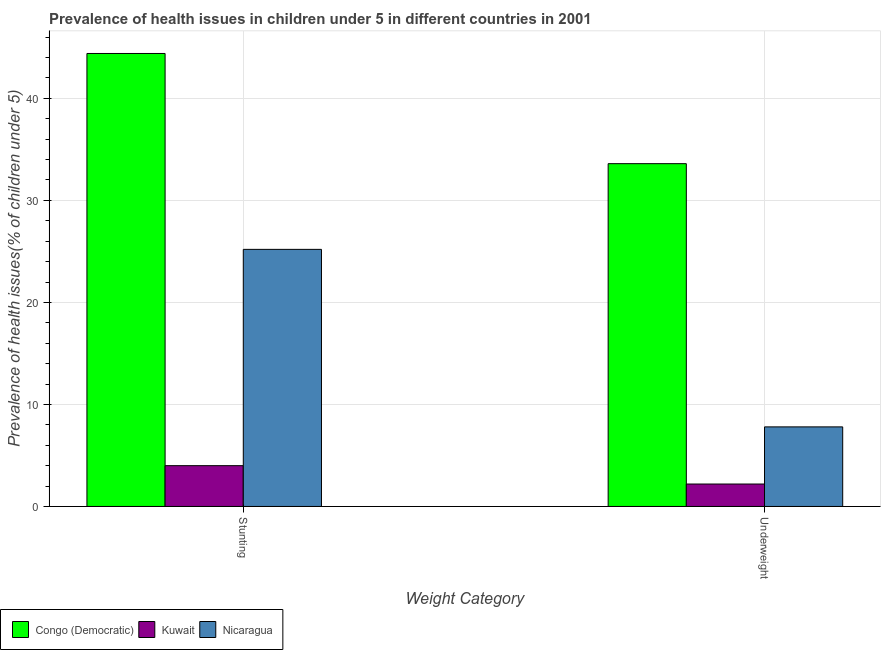Are the number of bars on each tick of the X-axis equal?
Give a very brief answer. Yes. How many bars are there on the 1st tick from the left?
Your answer should be compact. 3. How many bars are there on the 1st tick from the right?
Make the answer very short. 3. What is the label of the 2nd group of bars from the left?
Your answer should be very brief. Underweight. What is the percentage of stunted children in Nicaragua?
Your answer should be compact. 25.2. Across all countries, what is the maximum percentage of stunted children?
Provide a succinct answer. 44.4. Across all countries, what is the minimum percentage of underweight children?
Keep it short and to the point. 2.2. In which country was the percentage of underweight children maximum?
Ensure brevity in your answer.  Congo (Democratic). In which country was the percentage of underweight children minimum?
Ensure brevity in your answer.  Kuwait. What is the total percentage of underweight children in the graph?
Your answer should be very brief. 43.6. What is the difference between the percentage of underweight children in Congo (Democratic) and that in Nicaragua?
Offer a very short reply. 25.8. What is the difference between the percentage of underweight children in Nicaragua and the percentage of stunted children in Kuwait?
Offer a very short reply. 3.8. What is the average percentage of stunted children per country?
Keep it short and to the point. 24.53. What is the difference between the percentage of stunted children and percentage of underweight children in Kuwait?
Provide a succinct answer. 1.8. What is the ratio of the percentage of underweight children in Nicaragua to that in Kuwait?
Keep it short and to the point. 3.55. In how many countries, is the percentage of underweight children greater than the average percentage of underweight children taken over all countries?
Your response must be concise. 1. What does the 2nd bar from the left in Underweight represents?
Keep it short and to the point. Kuwait. What does the 2nd bar from the right in Underweight represents?
Your answer should be compact. Kuwait. Are all the bars in the graph horizontal?
Your response must be concise. No. Are the values on the major ticks of Y-axis written in scientific E-notation?
Offer a terse response. No. Does the graph contain any zero values?
Your response must be concise. No. Does the graph contain grids?
Offer a terse response. Yes. Where does the legend appear in the graph?
Your response must be concise. Bottom left. What is the title of the graph?
Your answer should be very brief. Prevalence of health issues in children under 5 in different countries in 2001. Does "Curacao" appear as one of the legend labels in the graph?
Offer a terse response. No. What is the label or title of the X-axis?
Give a very brief answer. Weight Category. What is the label or title of the Y-axis?
Make the answer very short. Prevalence of health issues(% of children under 5). What is the Prevalence of health issues(% of children under 5) in Congo (Democratic) in Stunting?
Your response must be concise. 44.4. What is the Prevalence of health issues(% of children under 5) of Nicaragua in Stunting?
Your answer should be compact. 25.2. What is the Prevalence of health issues(% of children under 5) in Congo (Democratic) in Underweight?
Your response must be concise. 33.6. What is the Prevalence of health issues(% of children under 5) in Kuwait in Underweight?
Ensure brevity in your answer.  2.2. What is the Prevalence of health issues(% of children under 5) in Nicaragua in Underweight?
Give a very brief answer. 7.8. Across all Weight Category, what is the maximum Prevalence of health issues(% of children under 5) of Congo (Democratic)?
Give a very brief answer. 44.4. Across all Weight Category, what is the maximum Prevalence of health issues(% of children under 5) of Kuwait?
Your answer should be very brief. 4. Across all Weight Category, what is the maximum Prevalence of health issues(% of children under 5) in Nicaragua?
Your answer should be compact. 25.2. Across all Weight Category, what is the minimum Prevalence of health issues(% of children under 5) in Congo (Democratic)?
Offer a very short reply. 33.6. Across all Weight Category, what is the minimum Prevalence of health issues(% of children under 5) of Kuwait?
Your answer should be compact. 2.2. Across all Weight Category, what is the minimum Prevalence of health issues(% of children under 5) in Nicaragua?
Provide a succinct answer. 7.8. What is the total Prevalence of health issues(% of children under 5) of Congo (Democratic) in the graph?
Your answer should be very brief. 78. What is the total Prevalence of health issues(% of children under 5) in Kuwait in the graph?
Keep it short and to the point. 6.2. What is the total Prevalence of health issues(% of children under 5) of Nicaragua in the graph?
Provide a short and direct response. 33. What is the difference between the Prevalence of health issues(% of children under 5) in Kuwait in Stunting and that in Underweight?
Your answer should be compact. 1.8. What is the difference between the Prevalence of health issues(% of children under 5) in Nicaragua in Stunting and that in Underweight?
Make the answer very short. 17.4. What is the difference between the Prevalence of health issues(% of children under 5) in Congo (Democratic) in Stunting and the Prevalence of health issues(% of children under 5) in Kuwait in Underweight?
Offer a terse response. 42.2. What is the difference between the Prevalence of health issues(% of children under 5) of Congo (Democratic) in Stunting and the Prevalence of health issues(% of children under 5) of Nicaragua in Underweight?
Make the answer very short. 36.6. What is the difference between the Prevalence of health issues(% of children under 5) in Kuwait in Stunting and the Prevalence of health issues(% of children under 5) in Nicaragua in Underweight?
Your response must be concise. -3.8. What is the average Prevalence of health issues(% of children under 5) in Congo (Democratic) per Weight Category?
Your answer should be compact. 39. What is the difference between the Prevalence of health issues(% of children under 5) in Congo (Democratic) and Prevalence of health issues(% of children under 5) in Kuwait in Stunting?
Offer a terse response. 40.4. What is the difference between the Prevalence of health issues(% of children under 5) in Congo (Democratic) and Prevalence of health issues(% of children under 5) in Nicaragua in Stunting?
Offer a very short reply. 19.2. What is the difference between the Prevalence of health issues(% of children under 5) in Kuwait and Prevalence of health issues(% of children under 5) in Nicaragua in Stunting?
Give a very brief answer. -21.2. What is the difference between the Prevalence of health issues(% of children under 5) in Congo (Democratic) and Prevalence of health issues(% of children under 5) in Kuwait in Underweight?
Keep it short and to the point. 31.4. What is the difference between the Prevalence of health issues(% of children under 5) in Congo (Democratic) and Prevalence of health issues(% of children under 5) in Nicaragua in Underweight?
Your answer should be very brief. 25.8. What is the difference between the Prevalence of health issues(% of children under 5) of Kuwait and Prevalence of health issues(% of children under 5) of Nicaragua in Underweight?
Offer a very short reply. -5.6. What is the ratio of the Prevalence of health issues(% of children under 5) in Congo (Democratic) in Stunting to that in Underweight?
Make the answer very short. 1.32. What is the ratio of the Prevalence of health issues(% of children under 5) in Kuwait in Stunting to that in Underweight?
Provide a short and direct response. 1.82. What is the ratio of the Prevalence of health issues(% of children under 5) of Nicaragua in Stunting to that in Underweight?
Make the answer very short. 3.23. What is the difference between the highest and the second highest Prevalence of health issues(% of children under 5) in Congo (Democratic)?
Offer a terse response. 10.8. What is the difference between the highest and the second highest Prevalence of health issues(% of children under 5) of Kuwait?
Your response must be concise. 1.8. What is the difference between the highest and the second highest Prevalence of health issues(% of children under 5) in Nicaragua?
Ensure brevity in your answer.  17.4. What is the difference between the highest and the lowest Prevalence of health issues(% of children under 5) of Congo (Democratic)?
Give a very brief answer. 10.8. 